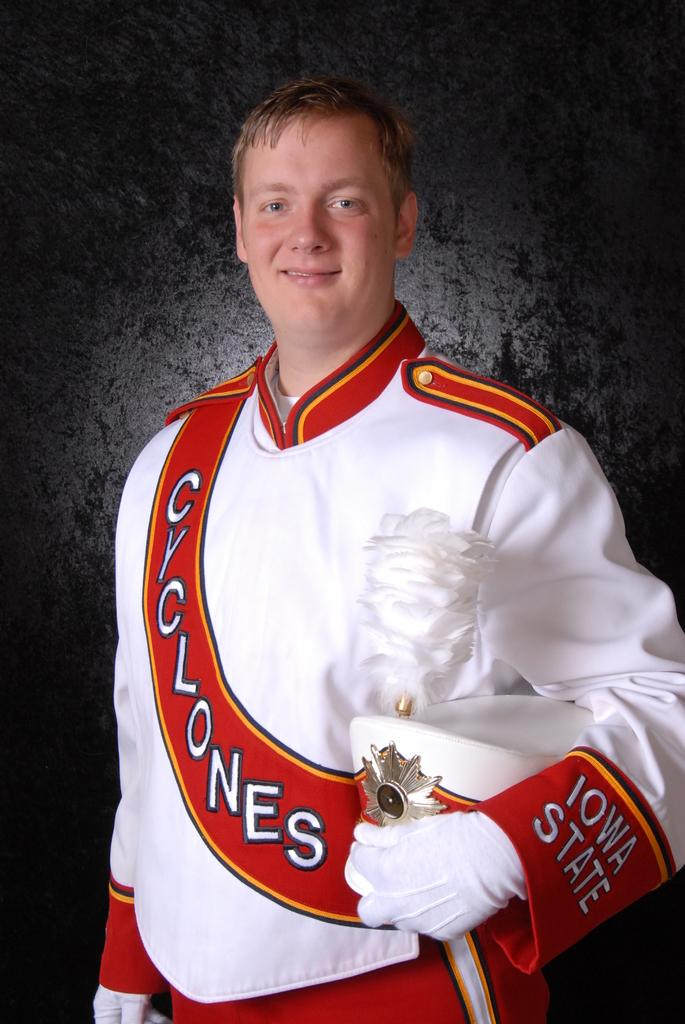Provide a one-sentence caption for the provided image. the word cyclones on an outfit that a person is wearing. 